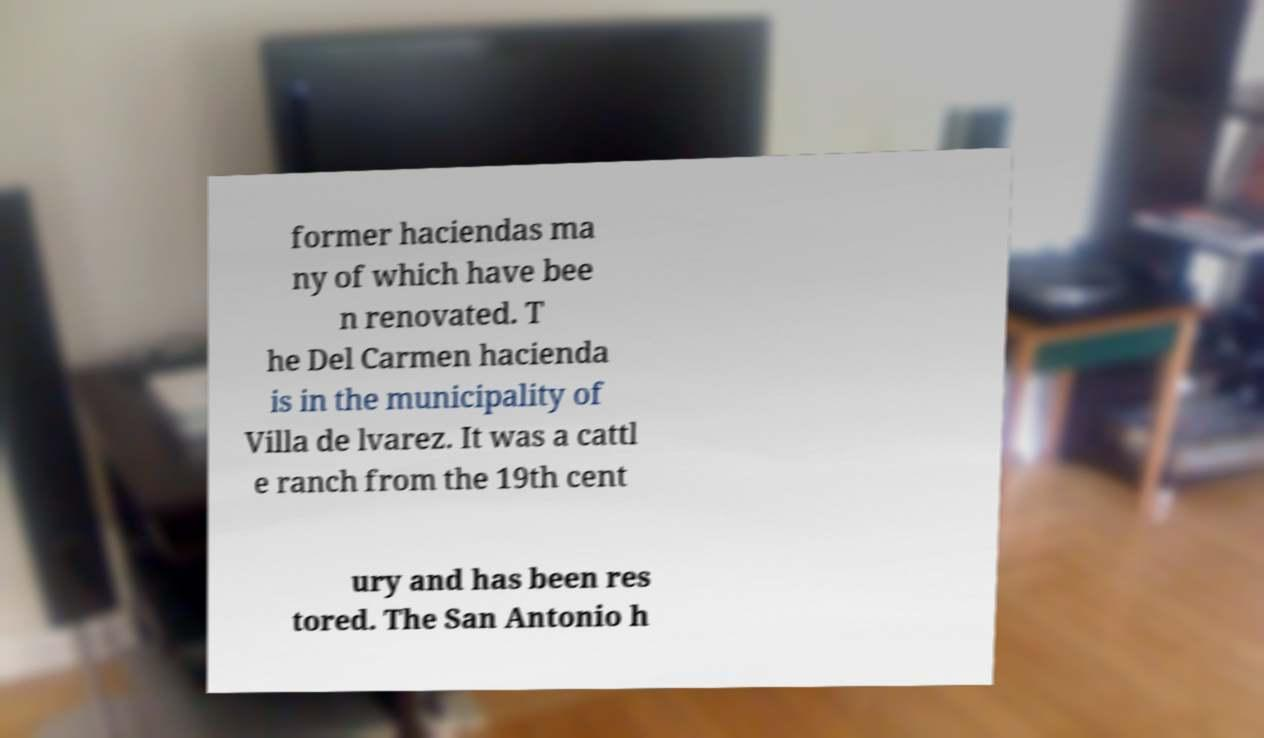For documentation purposes, I need the text within this image transcribed. Could you provide that? former haciendas ma ny of which have bee n renovated. T he Del Carmen hacienda is in the municipality of Villa de lvarez. It was a cattl e ranch from the 19th cent ury and has been res tored. The San Antonio h 